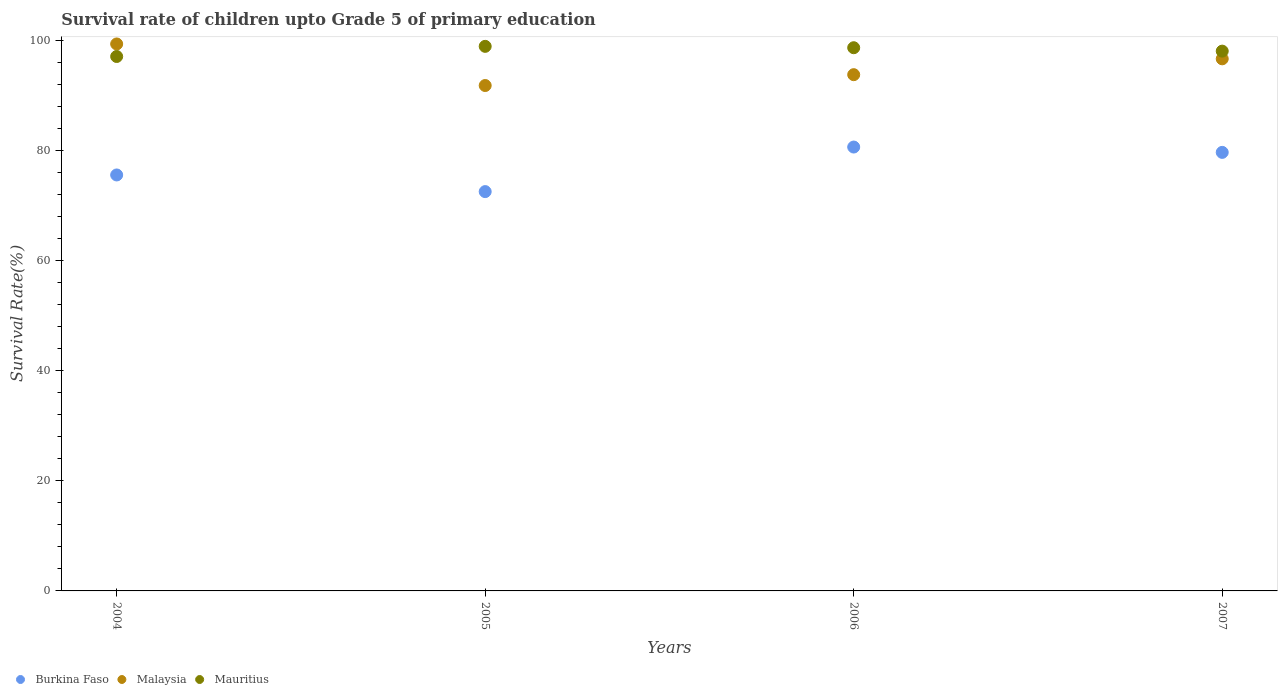How many different coloured dotlines are there?
Your answer should be very brief. 3. Is the number of dotlines equal to the number of legend labels?
Your response must be concise. Yes. What is the survival rate of children in Burkina Faso in 2005?
Give a very brief answer. 72.49. Across all years, what is the maximum survival rate of children in Mauritius?
Provide a short and direct response. 98.86. Across all years, what is the minimum survival rate of children in Mauritius?
Offer a terse response. 97.02. In which year was the survival rate of children in Malaysia maximum?
Provide a succinct answer. 2004. In which year was the survival rate of children in Mauritius minimum?
Make the answer very short. 2004. What is the total survival rate of children in Mauritius in the graph?
Provide a short and direct response. 392.47. What is the difference between the survival rate of children in Malaysia in 2004 and that in 2005?
Provide a succinct answer. 7.54. What is the difference between the survival rate of children in Malaysia in 2006 and the survival rate of children in Burkina Faso in 2004?
Give a very brief answer. 18.2. What is the average survival rate of children in Mauritius per year?
Make the answer very short. 98.12. In the year 2005, what is the difference between the survival rate of children in Malaysia and survival rate of children in Burkina Faso?
Provide a succinct answer. 19.26. In how many years, is the survival rate of children in Burkina Faso greater than 40 %?
Give a very brief answer. 4. What is the ratio of the survival rate of children in Mauritius in 2004 to that in 2007?
Your answer should be compact. 0.99. Is the survival rate of children in Mauritius in 2004 less than that in 2005?
Your answer should be compact. Yes. Is the difference between the survival rate of children in Malaysia in 2005 and 2007 greater than the difference between the survival rate of children in Burkina Faso in 2005 and 2007?
Offer a very short reply. Yes. What is the difference between the highest and the second highest survival rate of children in Mauritius?
Your response must be concise. 0.25. What is the difference between the highest and the lowest survival rate of children in Mauritius?
Keep it short and to the point. 1.84. In how many years, is the survival rate of children in Malaysia greater than the average survival rate of children in Malaysia taken over all years?
Offer a very short reply. 2. Is the sum of the survival rate of children in Malaysia in 2004 and 2006 greater than the maximum survival rate of children in Burkina Faso across all years?
Offer a terse response. Yes. Is it the case that in every year, the sum of the survival rate of children in Burkina Faso and survival rate of children in Malaysia  is greater than the survival rate of children in Mauritius?
Provide a succinct answer. Yes. Does the survival rate of children in Malaysia monotonically increase over the years?
Keep it short and to the point. No. Is the survival rate of children in Mauritius strictly greater than the survival rate of children in Burkina Faso over the years?
Your answer should be very brief. Yes. How many dotlines are there?
Your answer should be very brief. 3. How many years are there in the graph?
Provide a short and direct response. 4. What is the difference between two consecutive major ticks on the Y-axis?
Offer a terse response. 20. Are the values on the major ticks of Y-axis written in scientific E-notation?
Your answer should be very brief. No. Does the graph contain grids?
Provide a short and direct response. No. What is the title of the graph?
Keep it short and to the point. Survival rate of children upto Grade 5 of primary education. What is the label or title of the Y-axis?
Ensure brevity in your answer.  Survival Rate(%). What is the Survival Rate(%) of Burkina Faso in 2004?
Provide a short and direct response. 75.51. What is the Survival Rate(%) in Malaysia in 2004?
Provide a short and direct response. 99.29. What is the Survival Rate(%) of Mauritius in 2004?
Your answer should be compact. 97.02. What is the Survival Rate(%) of Burkina Faso in 2005?
Your answer should be very brief. 72.49. What is the Survival Rate(%) in Malaysia in 2005?
Your answer should be compact. 91.75. What is the Survival Rate(%) of Mauritius in 2005?
Your answer should be compact. 98.86. What is the Survival Rate(%) in Burkina Faso in 2006?
Provide a short and direct response. 80.58. What is the Survival Rate(%) of Malaysia in 2006?
Provide a short and direct response. 93.72. What is the Survival Rate(%) in Mauritius in 2006?
Ensure brevity in your answer.  98.61. What is the Survival Rate(%) in Burkina Faso in 2007?
Give a very brief answer. 79.61. What is the Survival Rate(%) in Malaysia in 2007?
Keep it short and to the point. 96.59. What is the Survival Rate(%) in Mauritius in 2007?
Your response must be concise. 97.99. Across all years, what is the maximum Survival Rate(%) in Burkina Faso?
Ensure brevity in your answer.  80.58. Across all years, what is the maximum Survival Rate(%) in Malaysia?
Your answer should be very brief. 99.29. Across all years, what is the maximum Survival Rate(%) in Mauritius?
Keep it short and to the point. 98.86. Across all years, what is the minimum Survival Rate(%) in Burkina Faso?
Offer a very short reply. 72.49. Across all years, what is the minimum Survival Rate(%) in Malaysia?
Give a very brief answer. 91.75. Across all years, what is the minimum Survival Rate(%) in Mauritius?
Your response must be concise. 97.02. What is the total Survival Rate(%) in Burkina Faso in the graph?
Make the answer very short. 308.19. What is the total Survival Rate(%) in Malaysia in the graph?
Your answer should be compact. 381.35. What is the total Survival Rate(%) in Mauritius in the graph?
Make the answer very short. 392.47. What is the difference between the Survival Rate(%) of Burkina Faso in 2004 and that in 2005?
Your answer should be very brief. 3.02. What is the difference between the Survival Rate(%) in Malaysia in 2004 and that in 2005?
Offer a very short reply. 7.54. What is the difference between the Survival Rate(%) in Mauritius in 2004 and that in 2005?
Ensure brevity in your answer.  -1.84. What is the difference between the Survival Rate(%) in Burkina Faso in 2004 and that in 2006?
Your answer should be compact. -5.07. What is the difference between the Survival Rate(%) in Malaysia in 2004 and that in 2006?
Offer a very short reply. 5.58. What is the difference between the Survival Rate(%) of Mauritius in 2004 and that in 2006?
Ensure brevity in your answer.  -1.59. What is the difference between the Survival Rate(%) in Burkina Faso in 2004 and that in 2007?
Keep it short and to the point. -4.1. What is the difference between the Survival Rate(%) in Malaysia in 2004 and that in 2007?
Your answer should be compact. 2.7. What is the difference between the Survival Rate(%) in Mauritius in 2004 and that in 2007?
Keep it short and to the point. -0.97. What is the difference between the Survival Rate(%) of Burkina Faso in 2005 and that in 2006?
Your answer should be compact. -8.09. What is the difference between the Survival Rate(%) in Malaysia in 2005 and that in 2006?
Your answer should be compact. -1.97. What is the difference between the Survival Rate(%) in Mauritius in 2005 and that in 2006?
Your response must be concise. 0.25. What is the difference between the Survival Rate(%) of Burkina Faso in 2005 and that in 2007?
Provide a short and direct response. -7.12. What is the difference between the Survival Rate(%) in Malaysia in 2005 and that in 2007?
Give a very brief answer. -4.85. What is the difference between the Survival Rate(%) of Mauritius in 2005 and that in 2007?
Your answer should be very brief. 0.87. What is the difference between the Survival Rate(%) in Burkina Faso in 2006 and that in 2007?
Your response must be concise. 0.97. What is the difference between the Survival Rate(%) in Malaysia in 2006 and that in 2007?
Provide a succinct answer. -2.88. What is the difference between the Survival Rate(%) of Mauritius in 2006 and that in 2007?
Keep it short and to the point. 0.62. What is the difference between the Survival Rate(%) in Burkina Faso in 2004 and the Survival Rate(%) in Malaysia in 2005?
Make the answer very short. -16.24. What is the difference between the Survival Rate(%) in Burkina Faso in 2004 and the Survival Rate(%) in Mauritius in 2005?
Provide a short and direct response. -23.35. What is the difference between the Survival Rate(%) in Malaysia in 2004 and the Survival Rate(%) in Mauritius in 2005?
Your answer should be very brief. 0.44. What is the difference between the Survival Rate(%) in Burkina Faso in 2004 and the Survival Rate(%) in Malaysia in 2006?
Provide a short and direct response. -18.2. What is the difference between the Survival Rate(%) of Burkina Faso in 2004 and the Survival Rate(%) of Mauritius in 2006?
Keep it short and to the point. -23.1. What is the difference between the Survival Rate(%) in Malaysia in 2004 and the Survival Rate(%) in Mauritius in 2006?
Ensure brevity in your answer.  0.68. What is the difference between the Survival Rate(%) in Burkina Faso in 2004 and the Survival Rate(%) in Malaysia in 2007?
Keep it short and to the point. -21.08. What is the difference between the Survival Rate(%) in Burkina Faso in 2004 and the Survival Rate(%) in Mauritius in 2007?
Your answer should be very brief. -22.48. What is the difference between the Survival Rate(%) of Malaysia in 2004 and the Survival Rate(%) of Mauritius in 2007?
Provide a short and direct response. 1.3. What is the difference between the Survival Rate(%) in Burkina Faso in 2005 and the Survival Rate(%) in Malaysia in 2006?
Ensure brevity in your answer.  -21.23. What is the difference between the Survival Rate(%) of Burkina Faso in 2005 and the Survival Rate(%) of Mauritius in 2006?
Your response must be concise. -26.12. What is the difference between the Survival Rate(%) in Malaysia in 2005 and the Survival Rate(%) in Mauritius in 2006?
Your response must be concise. -6.86. What is the difference between the Survival Rate(%) of Burkina Faso in 2005 and the Survival Rate(%) of Malaysia in 2007?
Offer a terse response. -24.1. What is the difference between the Survival Rate(%) in Burkina Faso in 2005 and the Survival Rate(%) in Mauritius in 2007?
Offer a very short reply. -25.5. What is the difference between the Survival Rate(%) of Malaysia in 2005 and the Survival Rate(%) of Mauritius in 2007?
Provide a succinct answer. -6.24. What is the difference between the Survival Rate(%) of Burkina Faso in 2006 and the Survival Rate(%) of Malaysia in 2007?
Provide a succinct answer. -16.01. What is the difference between the Survival Rate(%) in Burkina Faso in 2006 and the Survival Rate(%) in Mauritius in 2007?
Ensure brevity in your answer.  -17.41. What is the difference between the Survival Rate(%) in Malaysia in 2006 and the Survival Rate(%) in Mauritius in 2007?
Keep it short and to the point. -4.27. What is the average Survival Rate(%) in Burkina Faso per year?
Give a very brief answer. 77.05. What is the average Survival Rate(%) in Malaysia per year?
Give a very brief answer. 95.34. What is the average Survival Rate(%) in Mauritius per year?
Your answer should be very brief. 98.12. In the year 2004, what is the difference between the Survival Rate(%) of Burkina Faso and Survival Rate(%) of Malaysia?
Your answer should be compact. -23.78. In the year 2004, what is the difference between the Survival Rate(%) in Burkina Faso and Survival Rate(%) in Mauritius?
Make the answer very short. -21.51. In the year 2004, what is the difference between the Survival Rate(%) of Malaysia and Survival Rate(%) of Mauritius?
Make the answer very short. 2.28. In the year 2005, what is the difference between the Survival Rate(%) in Burkina Faso and Survival Rate(%) in Malaysia?
Provide a short and direct response. -19.26. In the year 2005, what is the difference between the Survival Rate(%) in Burkina Faso and Survival Rate(%) in Mauritius?
Your response must be concise. -26.37. In the year 2005, what is the difference between the Survival Rate(%) of Malaysia and Survival Rate(%) of Mauritius?
Your response must be concise. -7.11. In the year 2006, what is the difference between the Survival Rate(%) of Burkina Faso and Survival Rate(%) of Malaysia?
Your response must be concise. -13.14. In the year 2006, what is the difference between the Survival Rate(%) of Burkina Faso and Survival Rate(%) of Mauritius?
Provide a short and direct response. -18.03. In the year 2006, what is the difference between the Survival Rate(%) of Malaysia and Survival Rate(%) of Mauritius?
Your answer should be compact. -4.89. In the year 2007, what is the difference between the Survival Rate(%) in Burkina Faso and Survival Rate(%) in Malaysia?
Keep it short and to the point. -16.98. In the year 2007, what is the difference between the Survival Rate(%) in Burkina Faso and Survival Rate(%) in Mauritius?
Provide a succinct answer. -18.38. In the year 2007, what is the difference between the Survival Rate(%) in Malaysia and Survival Rate(%) in Mauritius?
Make the answer very short. -1.4. What is the ratio of the Survival Rate(%) of Burkina Faso in 2004 to that in 2005?
Give a very brief answer. 1.04. What is the ratio of the Survival Rate(%) in Malaysia in 2004 to that in 2005?
Provide a succinct answer. 1.08. What is the ratio of the Survival Rate(%) in Mauritius in 2004 to that in 2005?
Give a very brief answer. 0.98. What is the ratio of the Survival Rate(%) of Burkina Faso in 2004 to that in 2006?
Keep it short and to the point. 0.94. What is the ratio of the Survival Rate(%) in Malaysia in 2004 to that in 2006?
Provide a succinct answer. 1.06. What is the ratio of the Survival Rate(%) of Mauritius in 2004 to that in 2006?
Your answer should be compact. 0.98. What is the ratio of the Survival Rate(%) of Burkina Faso in 2004 to that in 2007?
Provide a short and direct response. 0.95. What is the ratio of the Survival Rate(%) in Malaysia in 2004 to that in 2007?
Provide a short and direct response. 1.03. What is the ratio of the Survival Rate(%) in Mauritius in 2004 to that in 2007?
Your response must be concise. 0.99. What is the ratio of the Survival Rate(%) of Burkina Faso in 2005 to that in 2006?
Keep it short and to the point. 0.9. What is the ratio of the Survival Rate(%) of Burkina Faso in 2005 to that in 2007?
Your answer should be compact. 0.91. What is the ratio of the Survival Rate(%) in Malaysia in 2005 to that in 2007?
Your response must be concise. 0.95. What is the ratio of the Survival Rate(%) of Mauritius in 2005 to that in 2007?
Provide a short and direct response. 1.01. What is the ratio of the Survival Rate(%) in Burkina Faso in 2006 to that in 2007?
Offer a terse response. 1.01. What is the ratio of the Survival Rate(%) of Malaysia in 2006 to that in 2007?
Make the answer very short. 0.97. What is the ratio of the Survival Rate(%) in Mauritius in 2006 to that in 2007?
Ensure brevity in your answer.  1.01. What is the difference between the highest and the second highest Survival Rate(%) in Malaysia?
Your response must be concise. 2.7. What is the difference between the highest and the second highest Survival Rate(%) of Mauritius?
Offer a terse response. 0.25. What is the difference between the highest and the lowest Survival Rate(%) in Burkina Faso?
Provide a succinct answer. 8.09. What is the difference between the highest and the lowest Survival Rate(%) in Malaysia?
Keep it short and to the point. 7.54. What is the difference between the highest and the lowest Survival Rate(%) in Mauritius?
Provide a succinct answer. 1.84. 